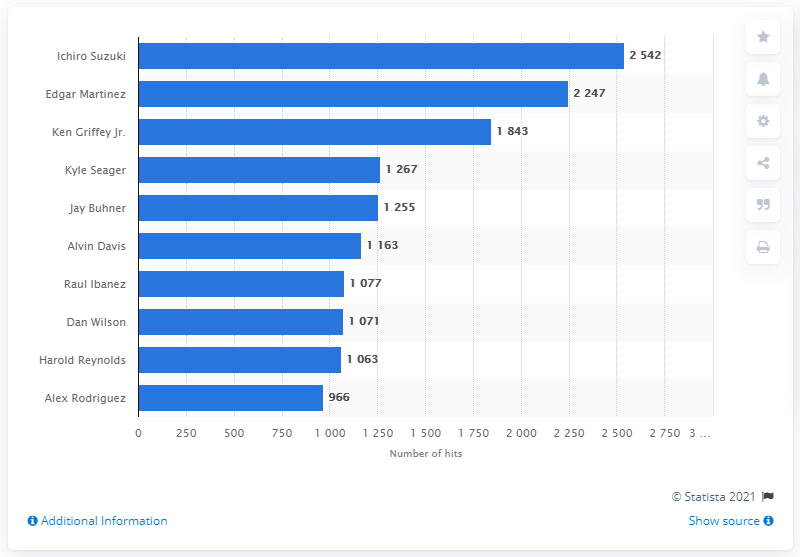Indicate a few pertinent items in this graphic. Ichiro Suzuki holds the record for the most hits in Seattle Mariners franchise history. 